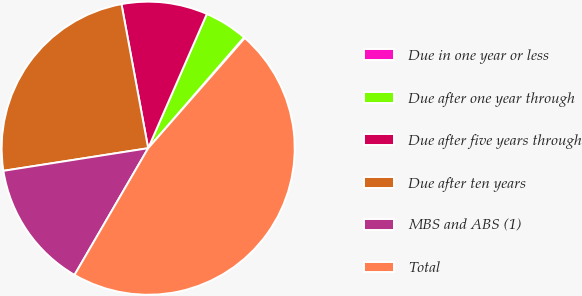<chart> <loc_0><loc_0><loc_500><loc_500><pie_chart><fcel>Due in one year or less<fcel>Due after one year through<fcel>Due after five years through<fcel>Due after ten years<fcel>MBS and ABS (1)<fcel>Total<nl><fcel>0.11%<fcel>4.79%<fcel>9.47%<fcel>24.55%<fcel>14.15%<fcel>46.92%<nl></chart> 